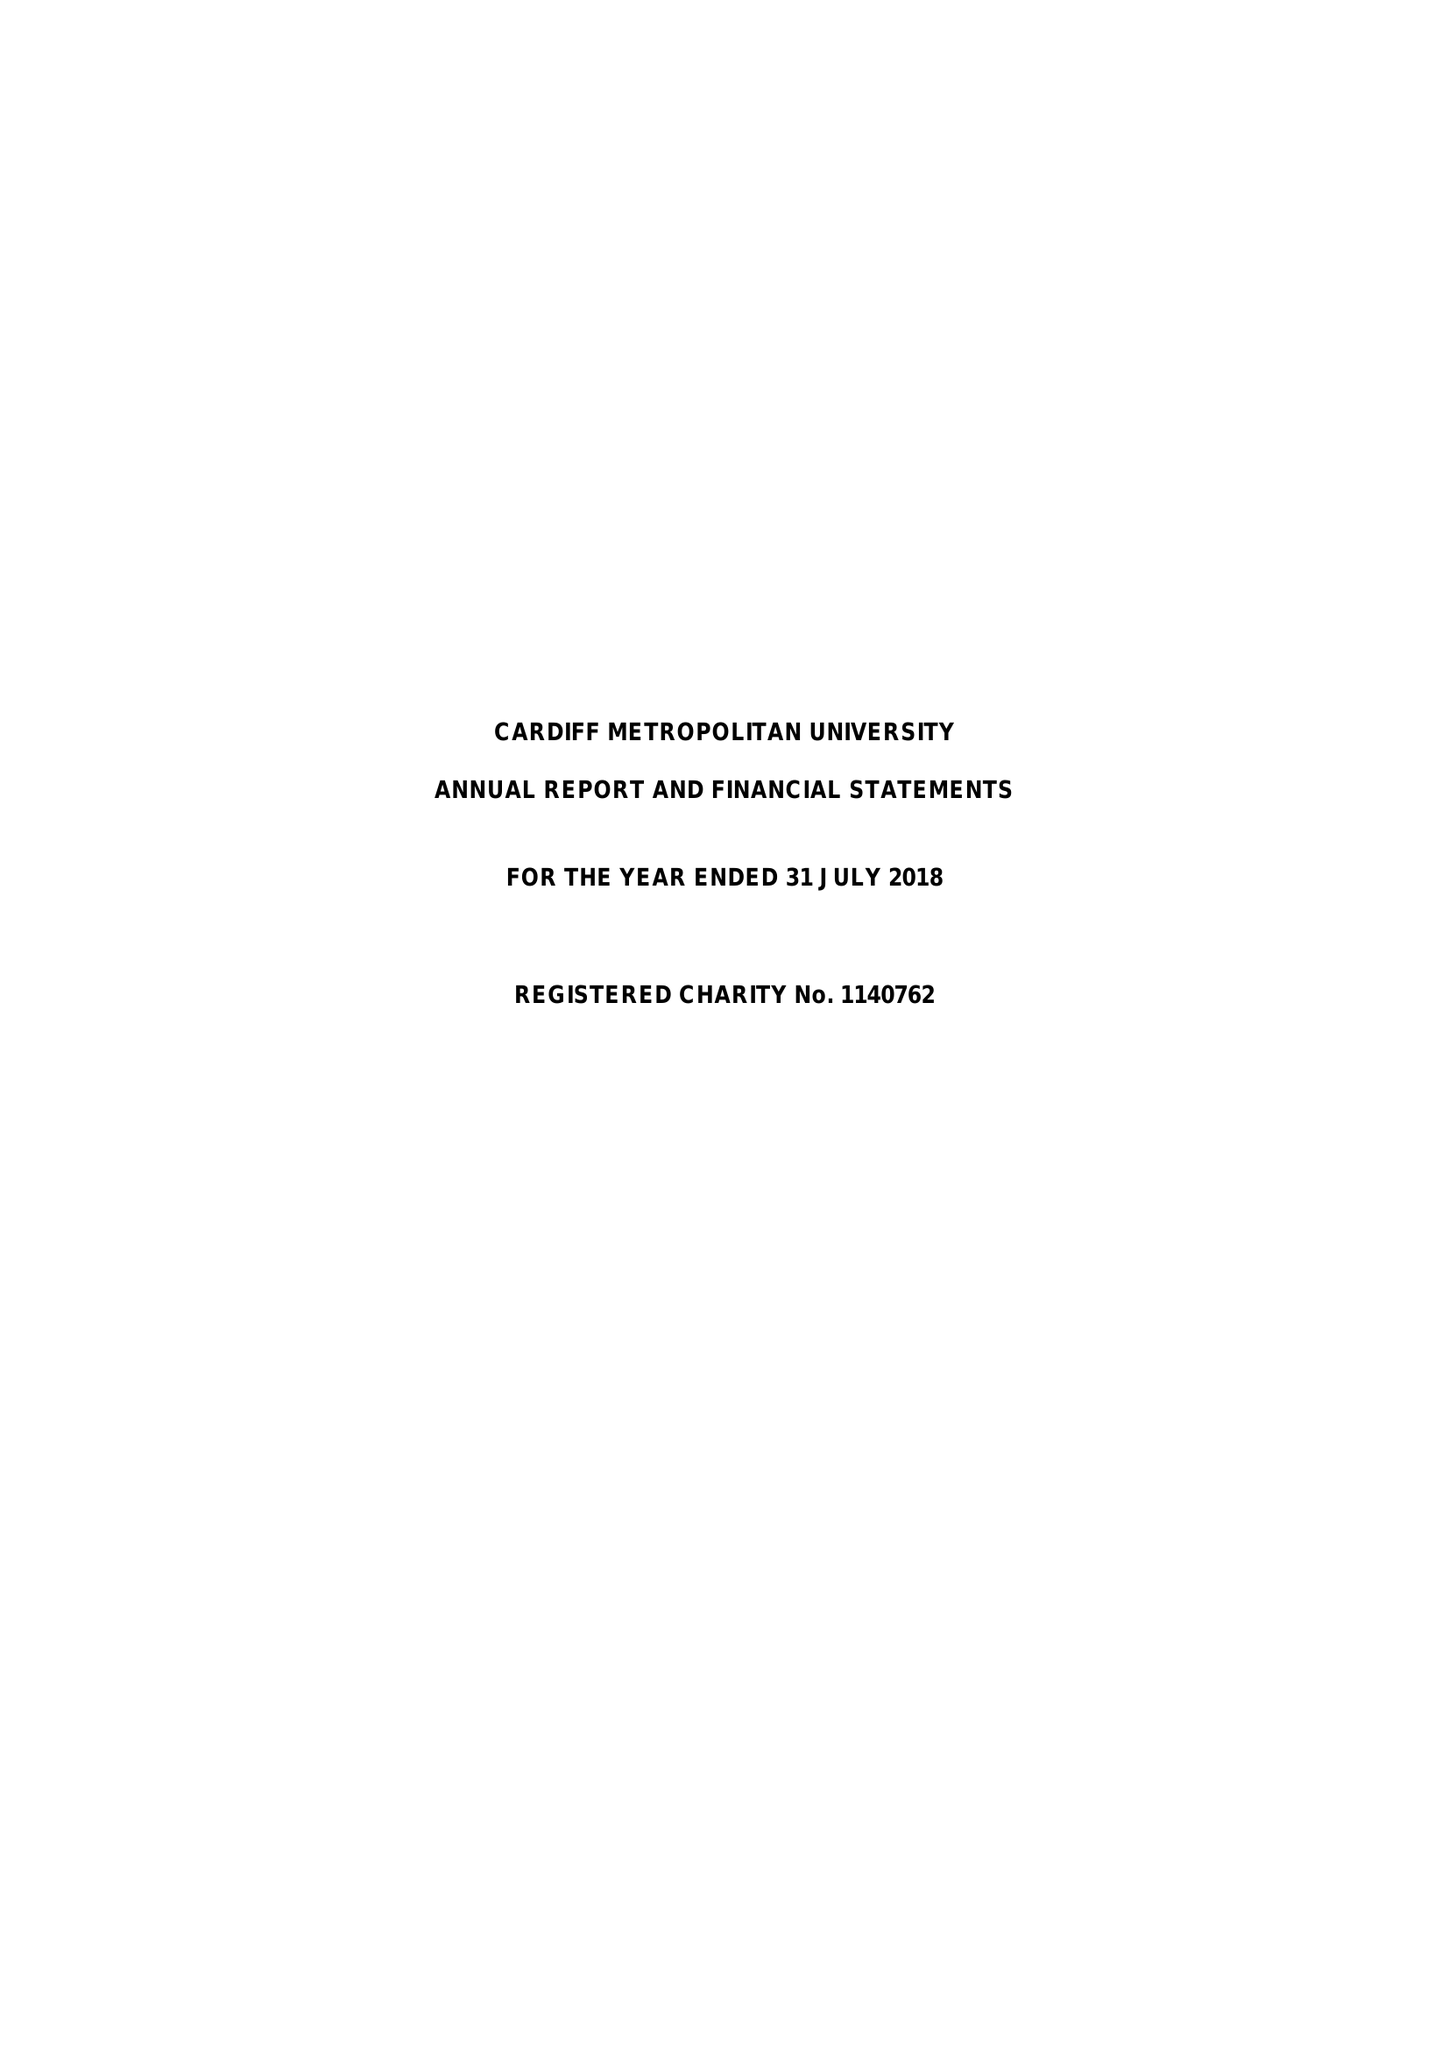What is the value for the charity_number?
Answer the question using a single word or phrase. 1140762 